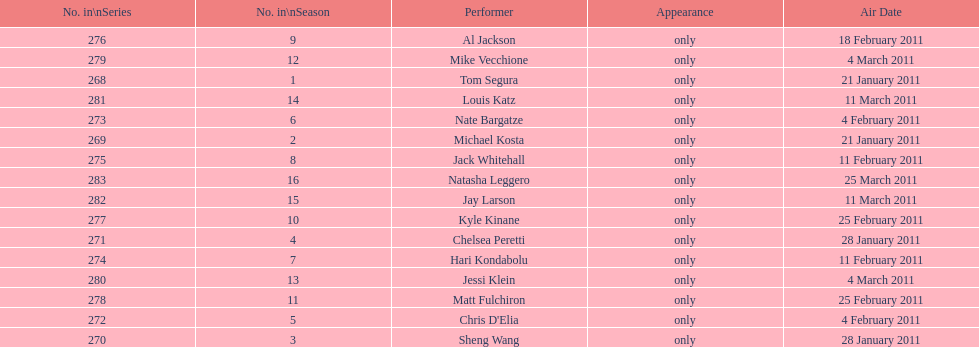How many weeks did season 15 of comedy central presents span? 9. 